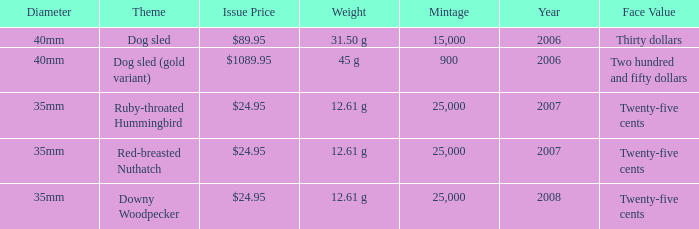What is the Diameter of the Dog Sled (gold variant) Theme coin? 40mm. 